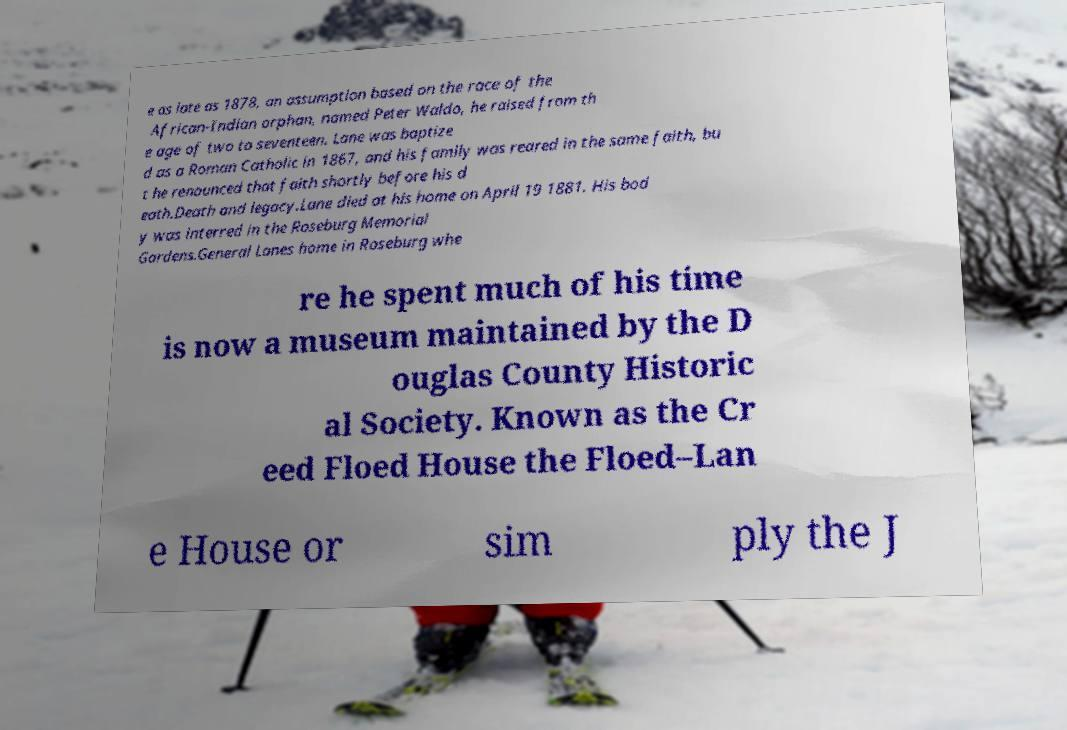I need the written content from this picture converted into text. Can you do that? e as late as 1878, an assumption based on the race of the African-Indian orphan, named Peter Waldo, he raised from th e age of two to seventeen. Lane was baptize d as a Roman Catholic in 1867, and his family was reared in the same faith, bu t he renounced that faith shortly before his d eath.Death and legacy.Lane died at his home on April 19 1881. His bod y was interred in the Roseburg Memorial Gardens.General Lanes home in Roseburg whe re he spent much of his time is now a museum maintained by the D ouglas County Historic al Society. Known as the Cr eed Floed House the Floed–Lan e House or sim ply the J 